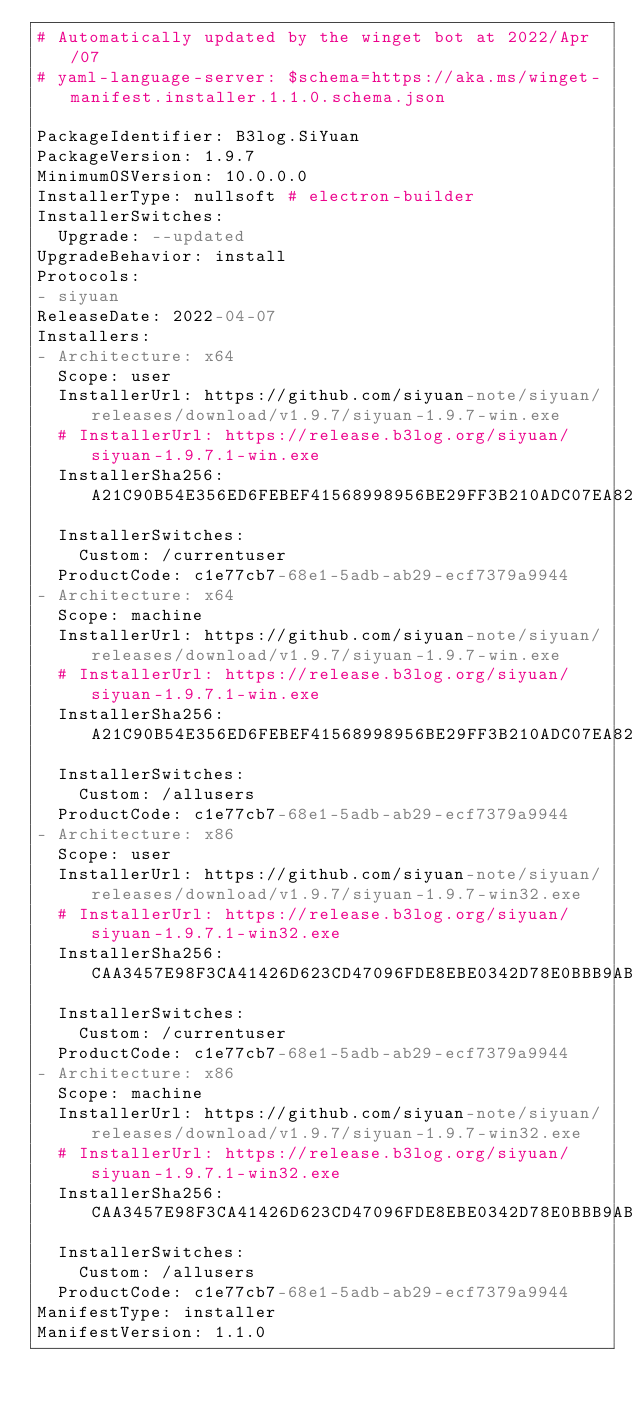<code> <loc_0><loc_0><loc_500><loc_500><_YAML_># Automatically updated by the winget bot at 2022/Apr/07
# yaml-language-server: $schema=https://aka.ms/winget-manifest.installer.1.1.0.schema.json

PackageIdentifier: B3log.SiYuan
PackageVersion: 1.9.7
MinimumOSVersion: 10.0.0.0
InstallerType: nullsoft # electron-builder
InstallerSwitches:
  Upgrade: --updated
UpgradeBehavior: install
Protocols:
- siyuan
ReleaseDate: 2022-04-07
Installers:
- Architecture: x64
  Scope: user
  InstallerUrl: https://github.com/siyuan-note/siyuan/releases/download/v1.9.7/siyuan-1.9.7-win.exe
  # InstallerUrl: https://release.b3log.org/siyuan/siyuan-1.9.7.1-win.exe
  InstallerSha256: A21C90B54E356ED6FEBEF41568998956BE29FF3B210ADC07EA825063A4E7B4D8
  InstallerSwitches:
    Custom: /currentuser
  ProductCode: c1e77cb7-68e1-5adb-ab29-ecf7379a9944
- Architecture: x64
  Scope: machine
  InstallerUrl: https://github.com/siyuan-note/siyuan/releases/download/v1.9.7/siyuan-1.9.7-win.exe
  # InstallerUrl: https://release.b3log.org/siyuan/siyuan-1.9.7.1-win.exe
  InstallerSha256: A21C90B54E356ED6FEBEF41568998956BE29FF3B210ADC07EA825063A4E7B4D8
  InstallerSwitches:
    Custom: /allusers
  ProductCode: c1e77cb7-68e1-5adb-ab29-ecf7379a9944
- Architecture: x86
  Scope: user
  InstallerUrl: https://github.com/siyuan-note/siyuan/releases/download/v1.9.7/siyuan-1.9.7-win32.exe
  # InstallerUrl: https://release.b3log.org/siyuan/siyuan-1.9.7.1-win32.exe
  InstallerSha256: CAA3457E98F3CA41426D623CD47096FDE8EBE0342D78E0BBB9AB2942B765445B
  InstallerSwitches:
    Custom: /currentuser
  ProductCode: c1e77cb7-68e1-5adb-ab29-ecf7379a9944
- Architecture: x86
  Scope: machine
  InstallerUrl: https://github.com/siyuan-note/siyuan/releases/download/v1.9.7/siyuan-1.9.7-win32.exe
  # InstallerUrl: https://release.b3log.org/siyuan/siyuan-1.9.7.1-win32.exe
  InstallerSha256: CAA3457E98F3CA41426D623CD47096FDE8EBE0342D78E0BBB9AB2942B765445B
  InstallerSwitches:
    Custom: /allusers
  ProductCode: c1e77cb7-68e1-5adb-ab29-ecf7379a9944
ManifestType: installer
ManifestVersion: 1.1.0
</code> 